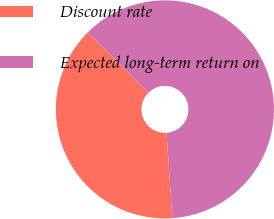Convert chart. <chart><loc_0><loc_0><loc_500><loc_500><pie_chart><fcel>Discount rate<fcel>Expected long-term return on<nl><fcel>38.6%<fcel>61.4%<nl></chart> 